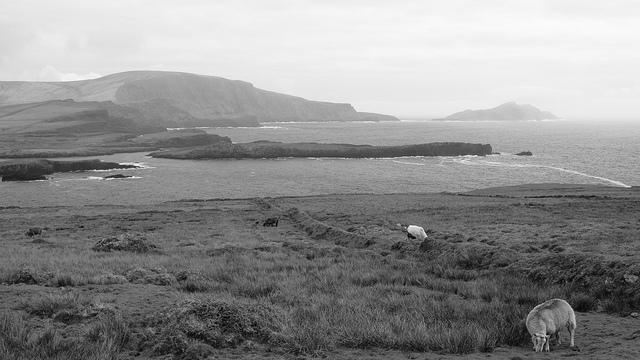How many animals in the picture?
Give a very brief answer. 2. How many skateboards do you see?
Give a very brief answer. 0. 